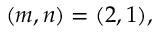<formula> <loc_0><loc_0><loc_500><loc_500>( m , n ) = ( 2 , 1 ) ,</formula> 